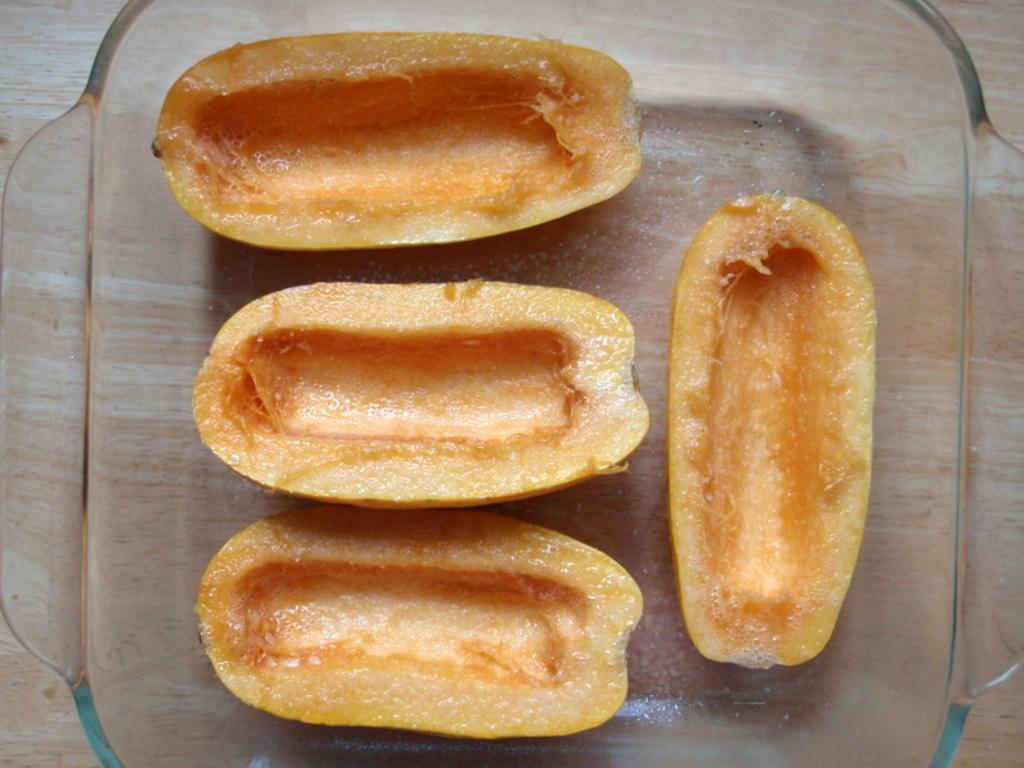What is the main object in the image? There is a table in the image. What is on the table? The table has a bowl on it. What is in the bowl? The bowl contains fruits. Is the key used to open the wilderness in the image? There is no key or wilderness present in the image. 